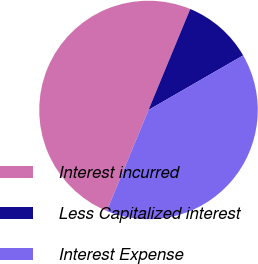<chart> <loc_0><loc_0><loc_500><loc_500><pie_chart><fcel>Interest incurred<fcel>Less Capitalized interest<fcel>Interest Expense<nl><fcel>50.0%<fcel>10.44%<fcel>39.56%<nl></chart> 